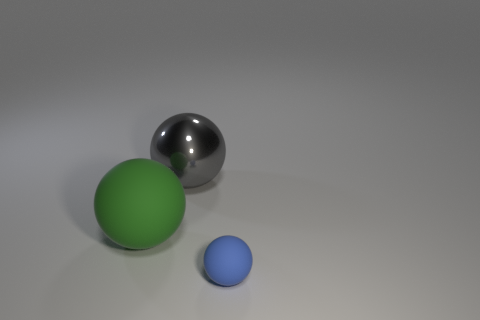Add 2 big objects. How many objects exist? 5 Add 1 big matte objects. How many big matte objects are left? 2 Add 2 cubes. How many cubes exist? 2 Subtract 0 cyan cylinders. How many objects are left? 3 Subtract all gray metal things. Subtract all blue spheres. How many objects are left? 1 